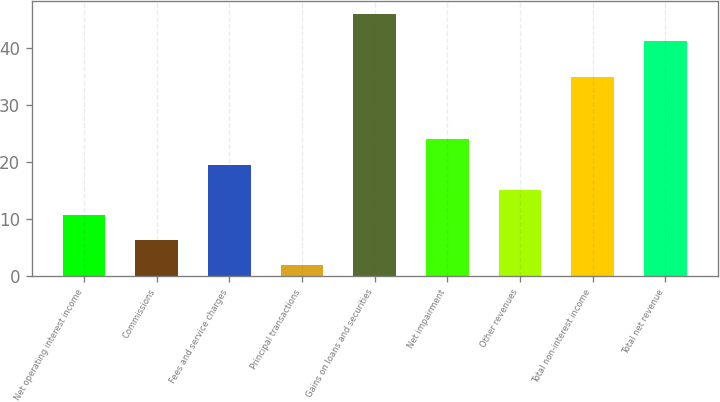Convert chart to OTSL. <chart><loc_0><loc_0><loc_500><loc_500><bar_chart><fcel>Net operating interest income<fcel>Commissions<fcel>Fees and service charges<fcel>Principal transactions<fcel>Gains on loans and securities<fcel>Net impairment<fcel>Other revenues<fcel>Total non-interest income<fcel>Total net revenue<nl><fcel>10.8<fcel>6.4<fcel>19.6<fcel>2<fcel>46<fcel>24<fcel>15.2<fcel>35<fcel>41.3<nl></chart> 